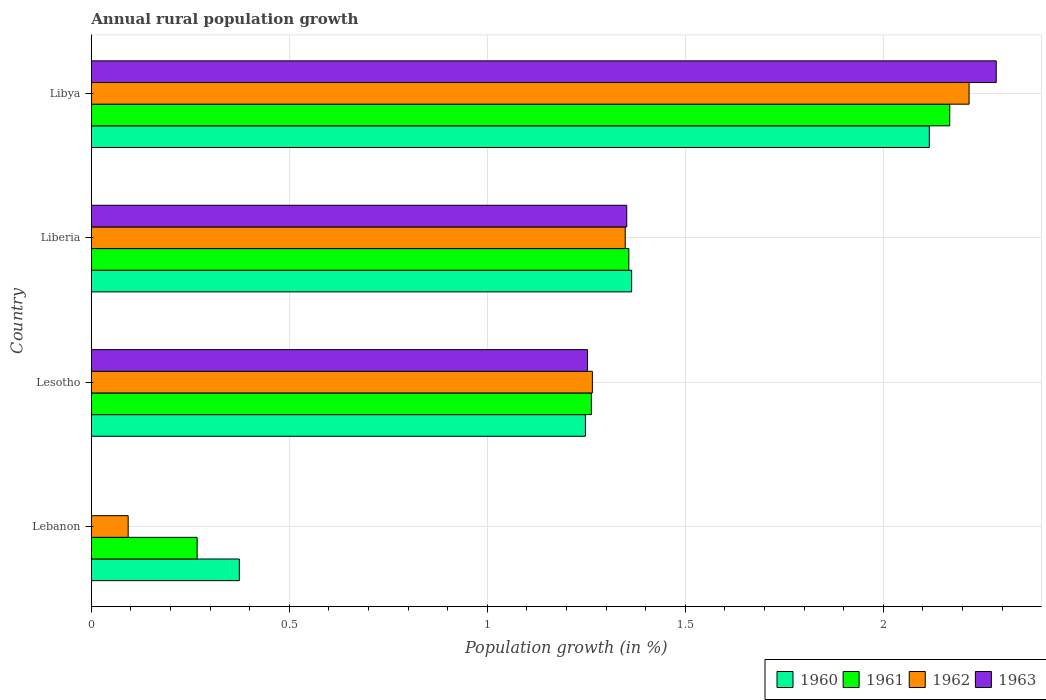How many different coloured bars are there?
Your answer should be compact. 4. Are the number of bars per tick equal to the number of legend labels?
Provide a short and direct response. No. How many bars are there on the 1st tick from the top?
Give a very brief answer. 4. How many bars are there on the 1st tick from the bottom?
Make the answer very short. 3. What is the label of the 3rd group of bars from the top?
Your answer should be very brief. Lesotho. In how many cases, is the number of bars for a given country not equal to the number of legend labels?
Provide a succinct answer. 1. What is the percentage of rural population growth in 1962 in Libya?
Keep it short and to the point. 2.22. Across all countries, what is the maximum percentage of rural population growth in 1962?
Provide a succinct answer. 2.22. Across all countries, what is the minimum percentage of rural population growth in 1960?
Offer a very short reply. 0.37. In which country was the percentage of rural population growth in 1962 maximum?
Offer a terse response. Libya. What is the total percentage of rural population growth in 1960 in the graph?
Keep it short and to the point. 5.1. What is the difference between the percentage of rural population growth in 1962 in Lebanon and that in Lesotho?
Your answer should be compact. -1.17. What is the difference between the percentage of rural population growth in 1960 in Liberia and the percentage of rural population growth in 1963 in Lesotho?
Make the answer very short. 0.11. What is the average percentage of rural population growth in 1963 per country?
Your answer should be compact. 1.22. What is the difference between the percentage of rural population growth in 1963 and percentage of rural population growth in 1960 in Lesotho?
Make the answer very short. 0.01. What is the ratio of the percentage of rural population growth in 1962 in Liberia to that in Libya?
Your answer should be compact. 0.61. What is the difference between the highest and the second highest percentage of rural population growth in 1963?
Offer a very short reply. 0.93. What is the difference between the highest and the lowest percentage of rural population growth in 1963?
Provide a short and direct response. 2.29. Is the sum of the percentage of rural population growth in 1960 in Lebanon and Lesotho greater than the maximum percentage of rural population growth in 1963 across all countries?
Ensure brevity in your answer.  No. Is it the case that in every country, the sum of the percentage of rural population growth in 1961 and percentage of rural population growth in 1963 is greater than the percentage of rural population growth in 1960?
Your answer should be compact. No. How many bars are there?
Your answer should be very brief. 15. Are all the bars in the graph horizontal?
Offer a terse response. Yes. How many countries are there in the graph?
Keep it short and to the point. 4. Are the values on the major ticks of X-axis written in scientific E-notation?
Offer a terse response. No. Where does the legend appear in the graph?
Ensure brevity in your answer.  Bottom right. How are the legend labels stacked?
Give a very brief answer. Horizontal. What is the title of the graph?
Offer a terse response. Annual rural population growth. Does "2009" appear as one of the legend labels in the graph?
Offer a very short reply. No. What is the label or title of the X-axis?
Make the answer very short. Population growth (in %). What is the Population growth (in %) of 1960 in Lebanon?
Ensure brevity in your answer.  0.37. What is the Population growth (in %) in 1961 in Lebanon?
Offer a terse response. 0.27. What is the Population growth (in %) of 1962 in Lebanon?
Your answer should be compact. 0.09. What is the Population growth (in %) in 1963 in Lebanon?
Make the answer very short. 0. What is the Population growth (in %) of 1960 in Lesotho?
Your answer should be very brief. 1.25. What is the Population growth (in %) in 1961 in Lesotho?
Give a very brief answer. 1.26. What is the Population growth (in %) in 1962 in Lesotho?
Ensure brevity in your answer.  1.27. What is the Population growth (in %) in 1963 in Lesotho?
Give a very brief answer. 1.25. What is the Population growth (in %) of 1960 in Liberia?
Offer a terse response. 1.36. What is the Population growth (in %) of 1961 in Liberia?
Your answer should be compact. 1.36. What is the Population growth (in %) of 1962 in Liberia?
Ensure brevity in your answer.  1.35. What is the Population growth (in %) of 1963 in Liberia?
Provide a succinct answer. 1.35. What is the Population growth (in %) of 1960 in Libya?
Provide a short and direct response. 2.12. What is the Population growth (in %) of 1961 in Libya?
Your answer should be compact. 2.17. What is the Population growth (in %) in 1962 in Libya?
Keep it short and to the point. 2.22. What is the Population growth (in %) of 1963 in Libya?
Your answer should be compact. 2.29. Across all countries, what is the maximum Population growth (in %) of 1960?
Offer a terse response. 2.12. Across all countries, what is the maximum Population growth (in %) in 1961?
Offer a very short reply. 2.17. Across all countries, what is the maximum Population growth (in %) of 1962?
Provide a short and direct response. 2.22. Across all countries, what is the maximum Population growth (in %) in 1963?
Offer a terse response. 2.29. Across all countries, what is the minimum Population growth (in %) in 1960?
Offer a terse response. 0.37. Across all countries, what is the minimum Population growth (in %) in 1961?
Ensure brevity in your answer.  0.27. Across all countries, what is the minimum Population growth (in %) of 1962?
Provide a short and direct response. 0.09. What is the total Population growth (in %) of 1960 in the graph?
Offer a terse response. 5.1. What is the total Population growth (in %) in 1961 in the graph?
Ensure brevity in your answer.  5.05. What is the total Population growth (in %) of 1962 in the graph?
Make the answer very short. 4.92. What is the total Population growth (in %) in 1963 in the graph?
Your response must be concise. 4.89. What is the difference between the Population growth (in %) of 1960 in Lebanon and that in Lesotho?
Offer a very short reply. -0.87. What is the difference between the Population growth (in %) in 1961 in Lebanon and that in Lesotho?
Provide a short and direct response. -1. What is the difference between the Population growth (in %) in 1962 in Lebanon and that in Lesotho?
Make the answer very short. -1.17. What is the difference between the Population growth (in %) in 1960 in Lebanon and that in Liberia?
Give a very brief answer. -0.99. What is the difference between the Population growth (in %) of 1961 in Lebanon and that in Liberia?
Make the answer very short. -1.09. What is the difference between the Population growth (in %) in 1962 in Lebanon and that in Liberia?
Ensure brevity in your answer.  -1.26. What is the difference between the Population growth (in %) of 1960 in Lebanon and that in Libya?
Give a very brief answer. -1.74. What is the difference between the Population growth (in %) in 1961 in Lebanon and that in Libya?
Your response must be concise. -1.9. What is the difference between the Population growth (in %) of 1962 in Lebanon and that in Libya?
Your answer should be compact. -2.12. What is the difference between the Population growth (in %) of 1960 in Lesotho and that in Liberia?
Make the answer very short. -0.12. What is the difference between the Population growth (in %) in 1961 in Lesotho and that in Liberia?
Your answer should be compact. -0.09. What is the difference between the Population growth (in %) of 1962 in Lesotho and that in Liberia?
Make the answer very short. -0.08. What is the difference between the Population growth (in %) of 1963 in Lesotho and that in Liberia?
Make the answer very short. -0.1. What is the difference between the Population growth (in %) of 1960 in Lesotho and that in Libya?
Your answer should be compact. -0.87. What is the difference between the Population growth (in %) in 1961 in Lesotho and that in Libya?
Keep it short and to the point. -0.9. What is the difference between the Population growth (in %) in 1962 in Lesotho and that in Libya?
Your response must be concise. -0.95. What is the difference between the Population growth (in %) in 1963 in Lesotho and that in Libya?
Your answer should be compact. -1.03. What is the difference between the Population growth (in %) in 1960 in Liberia and that in Libya?
Provide a short and direct response. -0.75. What is the difference between the Population growth (in %) of 1961 in Liberia and that in Libya?
Your answer should be very brief. -0.81. What is the difference between the Population growth (in %) of 1962 in Liberia and that in Libya?
Your answer should be compact. -0.87. What is the difference between the Population growth (in %) of 1963 in Liberia and that in Libya?
Make the answer very short. -0.93. What is the difference between the Population growth (in %) of 1960 in Lebanon and the Population growth (in %) of 1961 in Lesotho?
Your response must be concise. -0.89. What is the difference between the Population growth (in %) of 1960 in Lebanon and the Population growth (in %) of 1962 in Lesotho?
Keep it short and to the point. -0.89. What is the difference between the Population growth (in %) of 1960 in Lebanon and the Population growth (in %) of 1963 in Lesotho?
Ensure brevity in your answer.  -0.88. What is the difference between the Population growth (in %) of 1961 in Lebanon and the Population growth (in %) of 1962 in Lesotho?
Offer a very short reply. -1. What is the difference between the Population growth (in %) of 1961 in Lebanon and the Population growth (in %) of 1963 in Lesotho?
Make the answer very short. -0.99. What is the difference between the Population growth (in %) in 1962 in Lebanon and the Population growth (in %) in 1963 in Lesotho?
Provide a short and direct response. -1.16. What is the difference between the Population growth (in %) of 1960 in Lebanon and the Population growth (in %) of 1961 in Liberia?
Give a very brief answer. -0.98. What is the difference between the Population growth (in %) of 1960 in Lebanon and the Population growth (in %) of 1962 in Liberia?
Make the answer very short. -0.97. What is the difference between the Population growth (in %) in 1960 in Lebanon and the Population growth (in %) in 1963 in Liberia?
Offer a terse response. -0.98. What is the difference between the Population growth (in %) of 1961 in Lebanon and the Population growth (in %) of 1962 in Liberia?
Your answer should be very brief. -1.08. What is the difference between the Population growth (in %) in 1961 in Lebanon and the Population growth (in %) in 1963 in Liberia?
Keep it short and to the point. -1.08. What is the difference between the Population growth (in %) of 1962 in Lebanon and the Population growth (in %) of 1963 in Liberia?
Your response must be concise. -1.26. What is the difference between the Population growth (in %) of 1960 in Lebanon and the Population growth (in %) of 1961 in Libya?
Offer a very short reply. -1.79. What is the difference between the Population growth (in %) of 1960 in Lebanon and the Population growth (in %) of 1962 in Libya?
Give a very brief answer. -1.84. What is the difference between the Population growth (in %) in 1960 in Lebanon and the Population growth (in %) in 1963 in Libya?
Offer a terse response. -1.91. What is the difference between the Population growth (in %) of 1961 in Lebanon and the Population growth (in %) of 1962 in Libya?
Offer a terse response. -1.95. What is the difference between the Population growth (in %) of 1961 in Lebanon and the Population growth (in %) of 1963 in Libya?
Your answer should be very brief. -2.02. What is the difference between the Population growth (in %) of 1962 in Lebanon and the Population growth (in %) of 1963 in Libya?
Give a very brief answer. -2.19. What is the difference between the Population growth (in %) in 1960 in Lesotho and the Population growth (in %) in 1961 in Liberia?
Make the answer very short. -0.11. What is the difference between the Population growth (in %) of 1960 in Lesotho and the Population growth (in %) of 1962 in Liberia?
Ensure brevity in your answer.  -0.1. What is the difference between the Population growth (in %) of 1960 in Lesotho and the Population growth (in %) of 1963 in Liberia?
Keep it short and to the point. -0.1. What is the difference between the Population growth (in %) of 1961 in Lesotho and the Population growth (in %) of 1962 in Liberia?
Keep it short and to the point. -0.09. What is the difference between the Population growth (in %) in 1961 in Lesotho and the Population growth (in %) in 1963 in Liberia?
Provide a succinct answer. -0.09. What is the difference between the Population growth (in %) in 1962 in Lesotho and the Population growth (in %) in 1963 in Liberia?
Make the answer very short. -0.09. What is the difference between the Population growth (in %) in 1960 in Lesotho and the Population growth (in %) in 1961 in Libya?
Offer a terse response. -0.92. What is the difference between the Population growth (in %) in 1960 in Lesotho and the Population growth (in %) in 1962 in Libya?
Your response must be concise. -0.97. What is the difference between the Population growth (in %) in 1960 in Lesotho and the Population growth (in %) in 1963 in Libya?
Offer a very short reply. -1.04. What is the difference between the Population growth (in %) in 1961 in Lesotho and the Population growth (in %) in 1962 in Libya?
Keep it short and to the point. -0.95. What is the difference between the Population growth (in %) of 1961 in Lesotho and the Population growth (in %) of 1963 in Libya?
Make the answer very short. -1.02. What is the difference between the Population growth (in %) in 1962 in Lesotho and the Population growth (in %) in 1963 in Libya?
Offer a terse response. -1.02. What is the difference between the Population growth (in %) in 1960 in Liberia and the Population growth (in %) in 1961 in Libya?
Offer a terse response. -0.8. What is the difference between the Population growth (in %) in 1960 in Liberia and the Population growth (in %) in 1962 in Libya?
Offer a terse response. -0.85. What is the difference between the Population growth (in %) of 1960 in Liberia and the Population growth (in %) of 1963 in Libya?
Provide a short and direct response. -0.92. What is the difference between the Population growth (in %) of 1961 in Liberia and the Population growth (in %) of 1962 in Libya?
Provide a succinct answer. -0.86. What is the difference between the Population growth (in %) in 1961 in Liberia and the Population growth (in %) in 1963 in Libya?
Keep it short and to the point. -0.93. What is the difference between the Population growth (in %) of 1962 in Liberia and the Population growth (in %) of 1963 in Libya?
Ensure brevity in your answer.  -0.94. What is the average Population growth (in %) in 1960 per country?
Keep it short and to the point. 1.28. What is the average Population growth (in %) of 1961 per country?
Give a very brief answer. 1.26. What is the average Population growth (in %) of 1962 per country?
Offer a very short reply. 1.23. What is the average Population growth (in %) in 1963 per country?
Ensure brevity in your answer.  1.22. What is the difference between the Population growth (in %) of 1960 and Population growth (in %) of 1961 in Lebanon?
Provide a short and direct response. 0.11. What is the difference between the Population growth (in %) of 1960 and Population growth (in %) of 1962 in Lebanon?
Make the answer very short. 0.28. What is the difference between the Population growth (in %) of 1961 and Population growth (in %) of 1962 in Lebanon?
Provide a short and direct response. 0.17. What is the difference between the Population growth (in %) of 1960 and Population growth (in %) of 1961 in Lesotho?
Give a very brief answer. -0.01. What is the difference between the Population growth (in %) of 1960 and Population growth (in %) of 1962 in Lesotho?
Provide a succinct answer. -0.02. What is the difference between the Population growth (in %) in 1960 and Population growth (in %) in 1963 in Lesotho?
Offer a terse response. -0.01. What is the difference between the Population growth (in %) in 1961 and Population growth (in %) in 1962 in Lesotho?
Your answer should be compact. -0. What is the difference between the Population growth (in %) of 1961 and Population growth (in %) of 1963 in Lesotho?
Your answer should be compact. 0.01. What is the difference between the Population growth (in %) in 1962 and Population growth (in %) in 1963 in Lesotho?
Provide a short and direct response. 0.01. What is the difference between the Population growth (in %) of 1960 and Population growth (in %) of 1961 in Liberia?
Provide a succinct answer. 0.01. What is the difference between the Population growth (in %) in 1960 and Population growth (in %) in 1962 in Liberia?
Your answer should be very brief. 0.02. What is the difference between the Population growth (in %) in 1960 and Population growth (in %) in 1963 in Liberia?
Your answer should be compact. 0.01. What is the difference between the Population growth (in %) in 1961 and Population growth (in %) in 1962 in Liberia?
Offer a very short reply. 0.01. What is the difference between the Population growth (in %) in 1961 and Population growth (in %) in 1963 in Liberia?
Give a very brief answer. 0.01. What is the difference between the Population growth (in %) in 1962 and Population growth (in %) in 1963 in Liberia?
Your answer should be compact. -0. What is the difference between the Population growth (in %) in 1960 and Population growth (in %) in 1961 in Libya?
Make the answer very short. -0.05. What is the difference between the Population growth (in %) of 1960 and Population growth (in %) of 1962 in Libya?
Your response must be concise. -0.1. What is the difference between the Population growth (in %) in 1960 and Population growth (in %) in 1963 in Libya?
Your answer should be very brief. -0.17. What is the difference between the Population growth (in %) in 1961 and Population growth (in %) in 1962 in Libya?
Your answer should be very brief. -0.05. What is the difference between the Population growth (in %) of 1961 and Population growth (in %) of 1963 in Libya?
Provide a succinct answer. -0.12. What is the difference between the Population growth (in %) in 1962 and Population growth (in %) in 1963 in Libya?
Provide a short and direct response. -0.07. What is the ratio of the Population growth (in %) in 1960 in Lebanon to that in Lesotho?
Keep it short and to the point. 0.3. What is the ratio of the Population growth (in %) of 1961 in Lebanon to that in Lesotho?
Offer a very short reply. 0.21. What is the ratio of the Population growth (in %) of 1962 in Lebanon to that in Lesotho?
Offer a terse response. 0.07. What is the ratio of the Population growth (in %) in 1960 in Lebanon to that in Liberia?
Provide a short and direct response. 0.27. What is the ratio of the Population growth (in %) in 1961 in Lebanon to that in Liberia?
Offer a very short reply. 0.2. What is the ratio of the Population growth (in %) of 1962 in Lebanon to that in Liberia?
Ensure brevity in your answer.  0.07. What is the ratio of the Population growth (in %) of 1960 in Lebanon to that in Libya?
Give a very brief answer. 0.18. What is the ratio of the Population growth (in %) in 1961 in Lebanon to that in Libya?
Offer a very short reply. 0.12. What is the ratio of the Population growth (in %) of 1962 in Lebanon to that in Libya?
Offer a very short reply. 0.04. What is the ratio of the Population growth (in %) in 1960 in Lesotho to that in Liberia?
Give a very brief answer. 0.91. What is the ratio of the Population growth (in %) in 1961 in Lesotho to that in Liberia?
Give a very brief answer. 0.93. What is the ratio of the Population growth (in %) in 1962 in Lesotho to that in Liberia?
Your response must be concise. 0.94. What is the ratio of the Population growth (in %) of 1963 in Lesotho to that in Liberia?
Keep it short and to the point. 0.93. What is the ratio of the Population growth (in %) in 1960 in Lesotho to that in Libya?
Your response must be concise. 0.59. What is the ratio of the Population growth (in %) in 1961 in Lesotho to that in Libya?
Ensure brevity in your answer.  0.58. What is the ratio of the Population growth (in %) of 1962 in Lesotho to that in Libya?
Your answer should be compact. 0.57. What is the ratio of the Population growth (in %) of 1963 in Lesotho to that in Libya?
Provide a succinct answer. 0.55. What is the ratio of the Population growth (in %) of 1960 in Liberia to that in Libya?
Offer a very short reply. 0.64. What is the ratio of the Population growth (in %) of 1961 in Liberia to that in Libya?
Make the answer very short. 0.63. What is the ratio of the Population growth (in %) of 1962 in Liberia to that in Libya?
Offer a terse response. 0.61. What is the ratio of the Population growth (in %) in 1963 in Liberia to that in Libya?
Make the answer very short. 0.59. What is the difference between the highest and the second highest Population growth (in %) in 1960?
Keep it short and to the point. 0.75. What is the difference between the highest and the second highest Population growth (in %) in 1961?
Give a very brief answer. 0.81. What is the difference between the highest and the second highest Population growth (in %) in 1962?
Your response must be concise. 0.87. What is the difference between the highest and the second highest Population growth (in %) of 1963?
Give a very brief answer. 0.93. What is the difference between the highest and the lowest Population growth (in %) of 1960?
Make the answer very short. 1.74. What is the difference between the highest and the lowest Population growth (in %) in 1961?
Provide a short and direct response. 1.9. What is the difference between the highest and the lowest Population growth (in %) in 1962?
Your answer should be compact. 2.12. What is the difference between the highest and the lowest Population growth (in %) of 1963?
Make the answer very short. 2.29. 